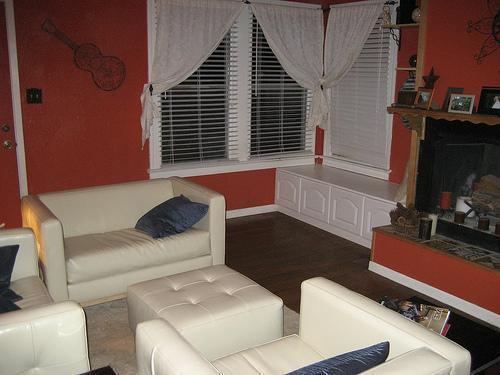How many people in the living room?
Give a very brief answer. 0. 